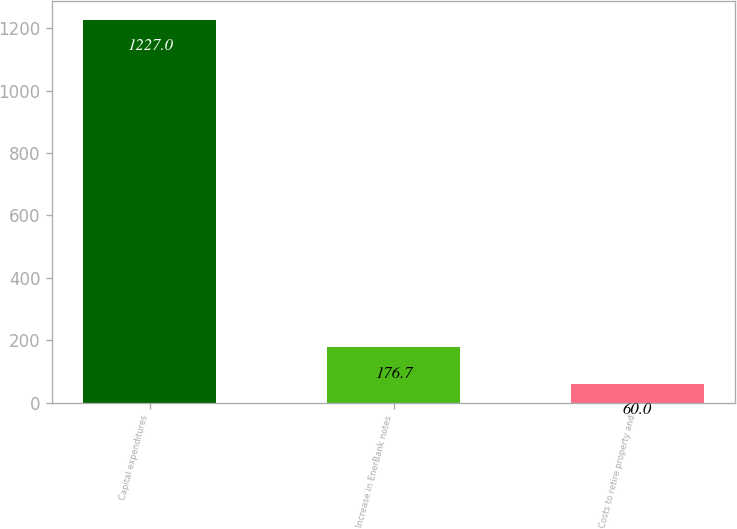<chart> <loc_0><loc_0><loc_500><loc_500><bar_chart><fcel>Capital expenditures<fcel>Increase in EnerBank notes<fcel>Costs to retire property and<nl><fcel>1227<fcel>176.7<fcel>60<nl></chart> 